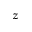Convert formula to latex. <formula><loc_0><loc_0><loc_500><loc_500>z</formula> 